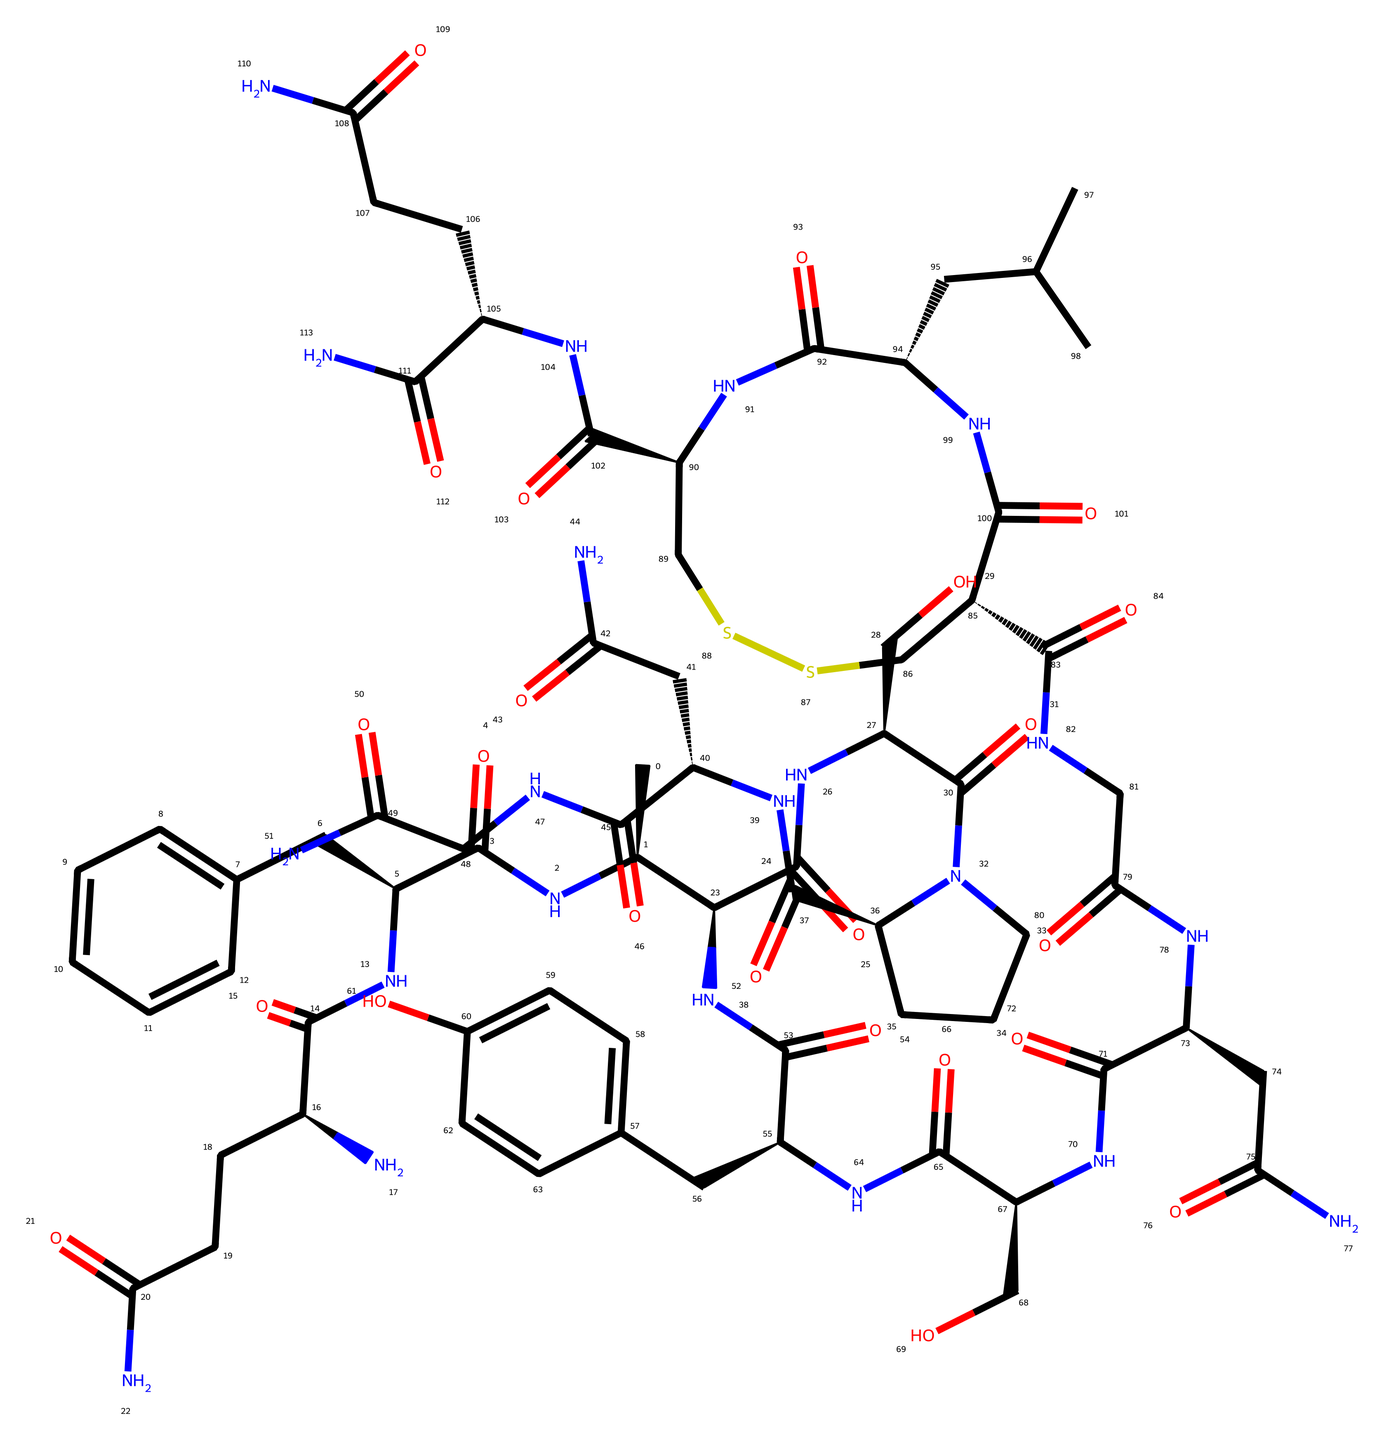What is the molecular formula represented by the chemical structure? To determine the molecular formula, count each element present in the chemical structure. Based on the visual representation, you can identify the number of Carbon (C), Hydrogen (H), Nitrogen (N), and Oxygen (O) atoms. A careful tally reveals the formula.
Answer: C45H66N12O12 How many rings are present in the structure? By visually inspecting the chemical structure, identify the closed-loop formations (rings). These are often represented as cyclic structures in the SMILES format, and based on careful observation, it looks like there are two distinct ring systems visible.
Answer: 2 What type of bonding is most prominent in this molecule? Analyzing the chemical, you can notice that the characteristic amide bonds (C(=O)N) and peptide bonds (joining amino acids) dominate the structure. This represents the connectivity and bonding framework of the hormone.
Answer: amide What biological function is oxytocin primarily known for? Oxytocin is well-known in biological contexts for its role in social bonding and trust among individuals. This function is significant in various physiological and psychological processes.
Answer: bonding How many nitrogen atoms are present in the structure? Counting the nitrogen atoms (N) from the breakdown of the chemical's structure provides insight into the complexity of the molecule. Each amine and amide segment contributes to the total. The count reveals a total of twelve nitrogen atoms.
Answer: 12 Is the chemical structure polarized? By evaluating the nature of the atoms (like the presence of highly electronegative oxygen and nitrogen), you can ascertain the overall polarity of the structure. The presence of multiple polar groups suggests that the molecule is indeed polar.
Answer: yes 